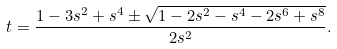Convert formula to latex. <formula><loc_0><loc_0><loc_500><loc_500>t = \frac { 1 - 3 s ^ { 2 } + s ^ { 4 } \pm \sqrt { 1 - 2 s ^ { 2 } - s ^ { 4 } - 2 s ^ { 6 } + s ^ { 8 } } } { 2 s ^ { 2 } } .</formula> 